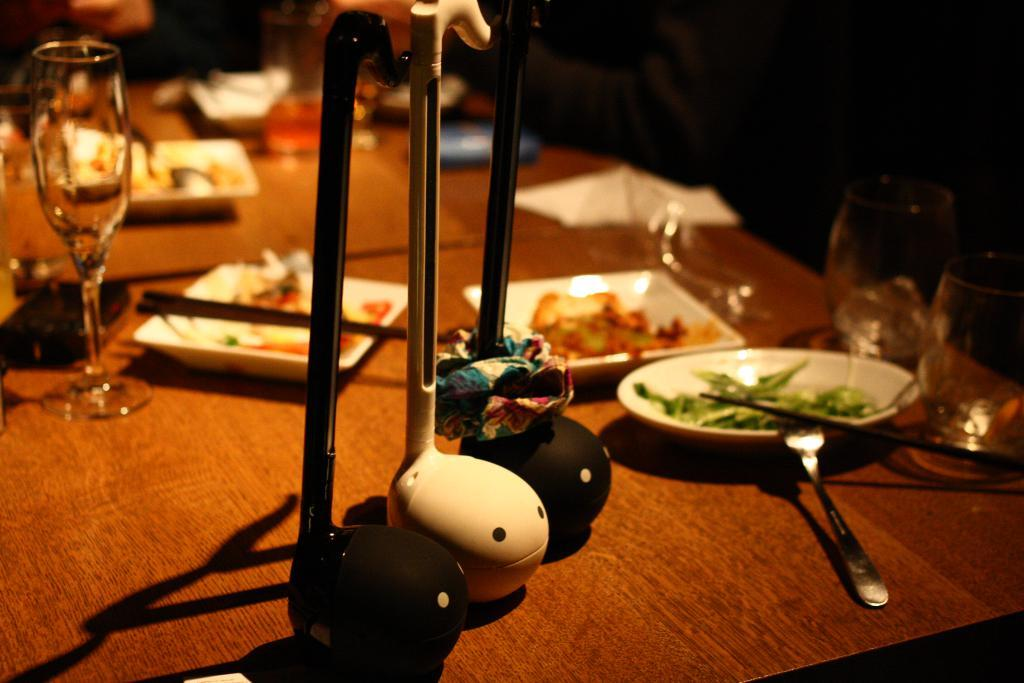Where was the image taken? The image was taken inside a restaurant. What can be seen in the image besides the restaurant setting? There is a table in the image. What is on the table in the image? Food and eatables are present on the table. How many unique stands are placed on the table? There are three unique stands placed on the table. How many hands are visible in the image? There is no mention of hands in the provided facts, so we cannot determine the number of hands visible in the image. 